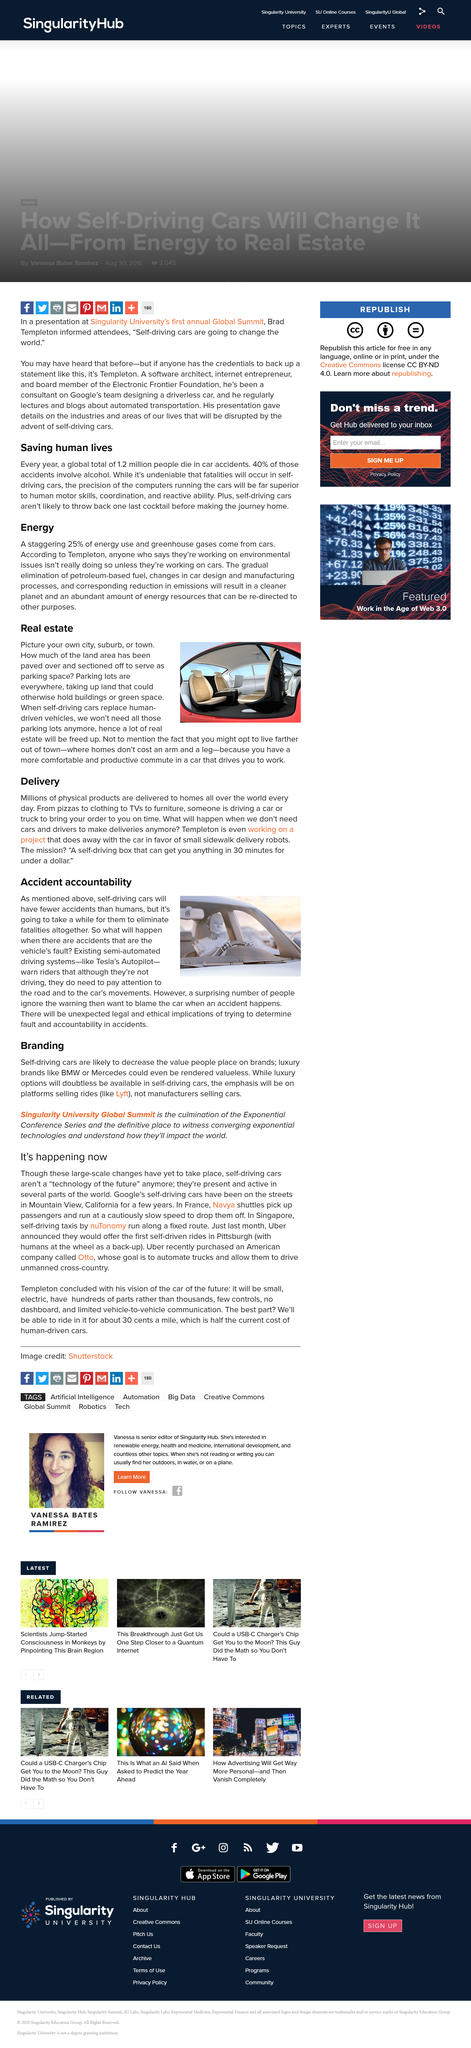Mention a couple of crucial points in this snapshot. Tesla's Autopilot is an example of a semi-automated driving system mentioned in the article as existing and being discussed in the context of the patent document. According to the article, it is expected that there will be unexpected legal and ethical implications when attempting to determine fault and hold individuals accountable for accidents. Self-driving cars will free up real estate by eliminating the need for parking spaces and reducing the demand for personal vehicles, thereby allowing for more efficient use of existing infrastructure. Parking lots take up a significant amount of land and consume valuable resources. The article claims that self-driving cars will have fewer accidents than human-driven cars. 